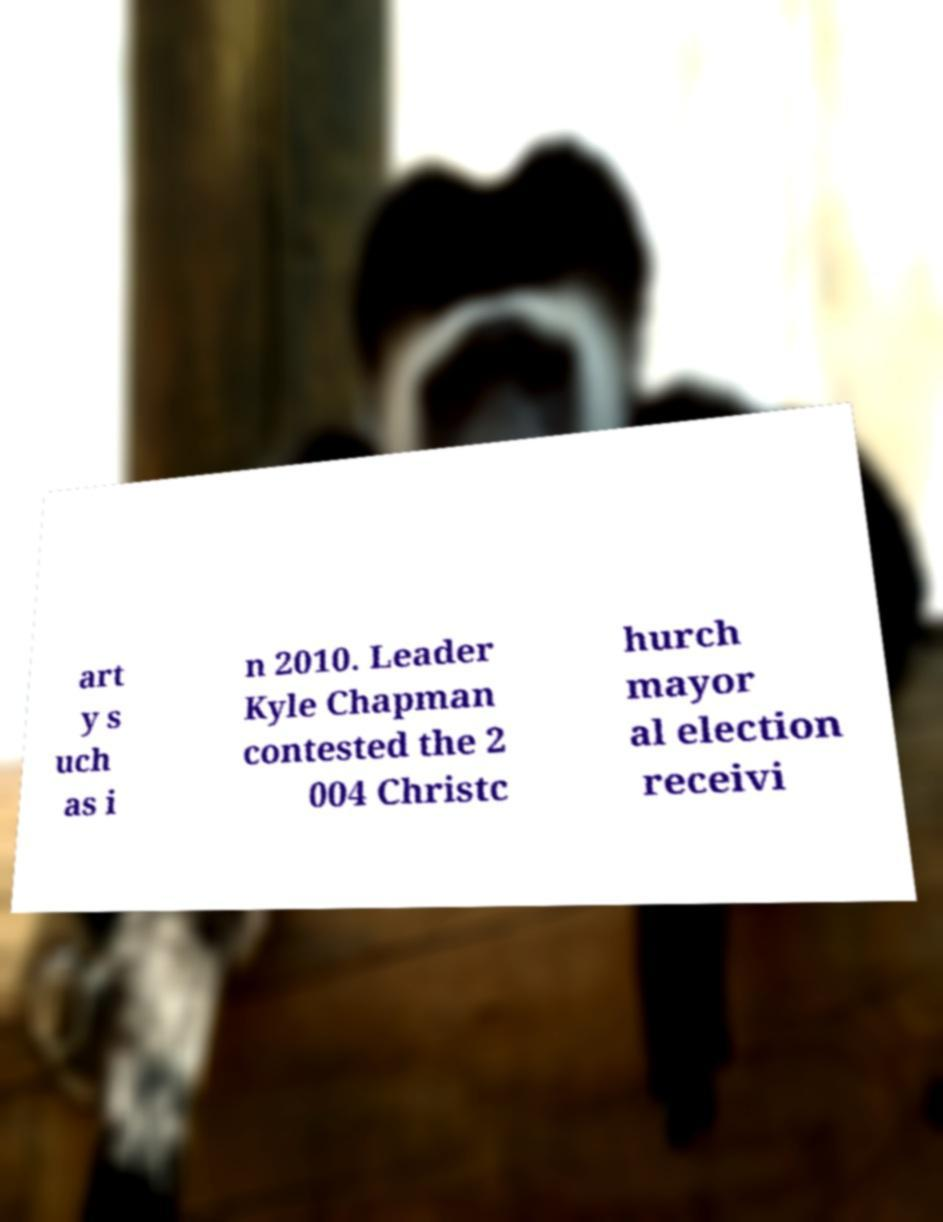Could you extract and type out the text from this image? art y s uch as i n 2010. Leader Kyle Chapman contested the 2 004 Christc hurch mayor al election receivi 